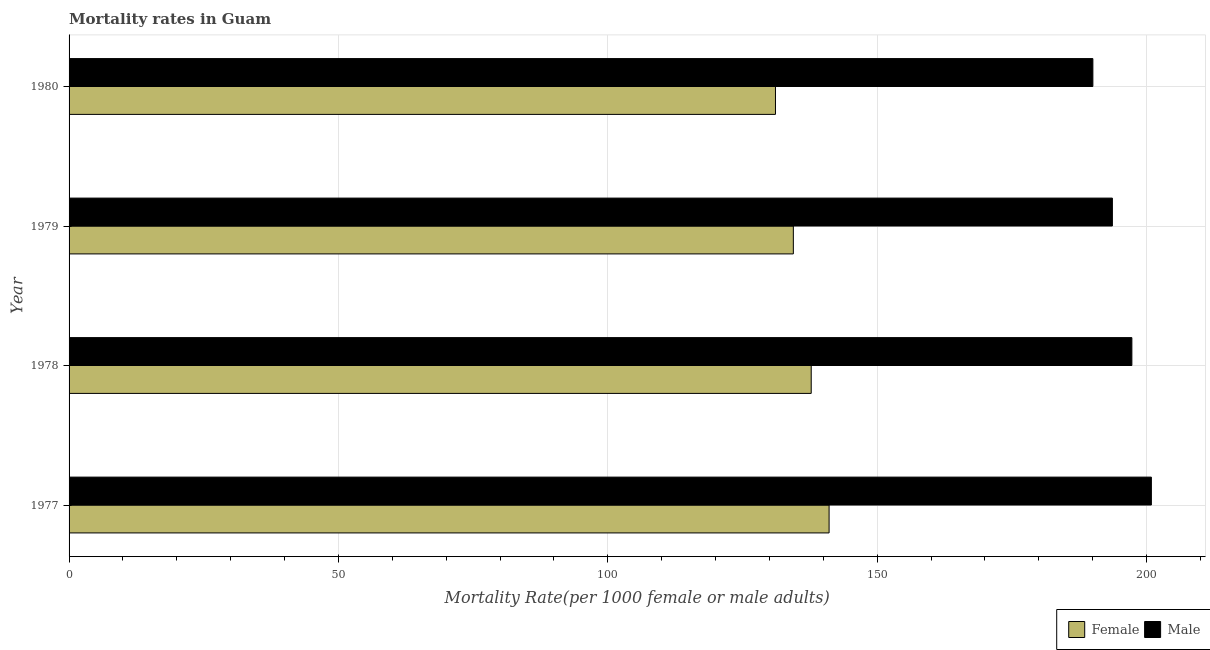How many groups of bars are there?
Provide a succinct answer. 4. Are the number of bars per tick equal to the number of legend labels?
Your answer should be compact. Yes. Are the number of bars on each tick of the Y-axis equal?
Provide a short and direct response. Yes. What is the male mortality rate in 1977?
Provide a short and direct response. 200.9. Across all years, what is the maximum male mortality rate?
Provide a succinct answer. 200.9. Across all years, what is the minimum male mortality rate?
Give a very brief answer. 190.04. What is the total male mortality rate in the graph?
Provide a short and direct response. 781.87. What is the difference between the female mortality rate in 1979 and that in 1980?
Your response must be concise. 3.32. What is the difference between the male mortality rate in 1977 and the female mortality rate in 1980?
Your answer should be compact. 69.78. What is the average female mortality rate per year?
Provide a short and direct response. 136.1. In the year 1979, what is the difference between the female mortality rate and male mortality rate?
Make the answer very short. -59.22. In how many years, is the female mortality rate greater than 10 ?
Provide a succinct answer. 4. What is the ratio of the female mortality rate in 1978 to that in 1980?
Your answer should be very brief. 1.05. Is the difference between the female mortality rate in 1977 and 1979 greater than the difference between the male mortality rate in 1977 and 1979?
Your answer should be very brief. No. What is the difference between the highest and the second highest female mortality rate?
Offer a very short reply. 3.32. What is the difference between the highest and the lowest female mortality rate?
Offer a very short reply. 9.95. Is the sum of the male mortality rate in 1979 and 1980 greater than the maximum female mortality rate across all years?
Offer a very short reply. Yes. What does the 1st bar from the top in 1978 represents?
Keep it short and to the point. Male. How many bars are there?
Provide a short and direct response. 8. Are all the bars in the graph horizontal?
Offer a terse response. Yes. How many years are there in the graph?
Your answer should be very brief. 4. Are the values on the major ticks of X-axis written in scientific E-notation?
Offer a very short reply. No. Does the graph contain grids?
Ensure brevity in your answer.  Yes. How many legend labels are there?
Your answer should be very brief. 2. What is the title of the graph?
Provide a succinct answer. Mortality rates in Guam. What is the label or title of the X-axis?
Give a very brief answer. Mortality Rate(per 1000 female or male adults). What is the Mortality Rate(per 1000 female or male adults) in Female in 1977?
Your answer should be very brief. 141.07. What is the Mortality Rate(per 1000 female or male adults) in Male in 1977?
Provide a short and direct response. 200.9. What is the Mortality Rate(per 1000 female or male adults) in Female in 1978?
Offer a terse response. 137.76. What is the Mortality Rate(per 1000 female or male adults) of Male in 1978?
Provide a succinct answer. 197.28. What is the Mortality Rate(per 1000 female or male adults) in Female in 1979?
Your response must be concise. 134.44. What is the Mortality Rate(per 1000 female or male adults) in Male in 1979?
Offer a terse response. 193.66. What is the Mortality Rate(per 1000 female or male adults) in Female in 1980?
Offer a very short reply. 131.12. What is the Mortality Rate(per 1000 female or male adults) of Male in 1980?
Your answer should be compact. 190.04. Across all years, what is the maximum Mortality Rate(per 1000 female or male adults) in Female?
Provide a succinct answer. 141.07. Across all years, what is the maximum Mortality Rate(per 1000 female or male adults) of Male?
Provide a succinct answer. 200.9. Across all years, what is the minimum Mortality Rate(per 1000 female or male adults) of Female?
Your response must be concise. 131.12. Across all years, what is the minimum Mortality Rate(per 1000 female or male adults) in Male?
Ensure brevity in your answer.  190.04. What is the total Mortality Rate(per 1000 female or male adults) in Female in the graph?
Provide a short and direct response. 544.39. What is the total Mortality Rate(per 1000 female or male adults) of Male in the graph?
Your response must be concise. 781.87. What is the difference between the Mortality Rate(per 1000 female or male adults) of Female in 1977 and that in 1978?
Your answer should be compact. 3.32. What is the difference between the Mortality Rate(per 1000 female or male adults) of Male in 1977 and that in 1978?
Give a very brief answer. 3.62. What is the difference between the Mortality Rate(per 1000 female or male adults) in Female in 1977 and that in 1979?
Your answer should be very brief. 6.64. What is the difference between the Mortality Rate(per 1000 female or male adults) of Male in 1977 and that in 1979?
Your answer should be very brief. 7.24. What is the difference between the Mortality Rate(per 1000 female or male adults) in Female in 1977 and that in 1980?
Give a very brief answer. 9.95. What is the difference between the Mortality Rate(per 1000 female or male adults) of Male in 1977 and that in 1980?
Keep it short and to the point. 10.86. What is the difference between the Mortality Rate(per 1000 female or male adults) in Female in 1978 and that in 1979?
Your response must be concise. 3.32. What is the difference between the Mortality Rate(per 1000 female or male adults) in Male in 1978 and that in 1979?
Provide a succinct answer. 3.62. What is the difference between the Mortality Rate(per 1000 female or male adults) of Female in 1978 and that in 1980?
Provide a short and direct response. 6.63. What is the difference between the Mortality Rate(per 1000 female or male adults) of Male in 1978 and that in 1980?
Your answer should be compact. 7.24. What is the difference between the Mortality Rate(per 1000 female or male adults) of Female in 1979 and that in 1980?
Give a very brief answer. 3.32. What is the difference between the Mortality Rate(per 1000 female or male adults) in Male in 1979 and that in 1980?
Provide a short and direct response. 3.62. What is the difference between the Mortality Rate(per 1000 female or male adults) in Female in 1977 and the Mortality Rate(per 1000 female or male adults) in Male in 1978?
Your answer should be very brief. -56.2. What is the difference between the Mortality Rate(per 1000 female or male adults) of Female in 1977 and the Mortality Rate(per 1000 female or male adults) of Male in 1979?
Give a very brief answer. -52.59. What is the difference between the Mortality Rate(per 1000 female or male adults) in Female in 1977 and the Mortality Rate(per 1000 female or male adults) in Male in 1980?
Your answer should be very brief. -48.97. What is the difference between the Mortality Rate(per 1000 female or male adults) of Female in 1978 and the Mortality Rate(per 1000 female or male adults) of Male in 1979?
Keep it short and to the point. -55.9. What is the difference between the Mortality Rate(per 1000 female or male adults) of Female in 1978 and the Mortality Rate(per 1000 female or male adults) of Male in 1980?
Keep it short and to the point. -52.28. What is the difference between the Mortality Rate(per 1000 female or male adults) of Female in 1979 and the Mortality Rate(per 1000 female or male adults) of Male in 1980?
Provide a succinct answer. -55.6. What is the average Mortality Rate(per 1000 female or male adults) of Female per year?
Make the answer very short. 136.1. What is the average Mortality Rate(per 1000 female or male adults) of Male per year?
Offer a very short reply. 195.47. In the year 1977, what is the difference between the Mortality Rate(per 1000 female or male adults) of Female and Mortality Rate(per 1000 female or male adults) of Male?
Provide a short and direct response. -59.82. In the year 1978, what is the difference between the Mortality Rate(per 1000 female or male adults) in Female and Mortality Rate(per 1000 female or male adults) in Male?
Your answer should be very brief. -59.52. In the year 1979, what is the difference between the Mortality Rate(per 1000 female or male adults) of Female and Mortality Rate(per 1000 female or male adults) of Male?
Give a very brief answer. -59.22. In the year 1980, what is the difference between the Mortality Rate(per 1000 female or male adults) in Female and Mortality Rate(per 1000 female or male adults) in Male?
Ensure brevity in your answer.  -58.92. What is the ratio of the Mortality Rate(per 1000 female or male adults) of Female in 1977 to that in 1978?
Your answer should be compact. 1.02. What is the ratio of the Mortality Rate(per 1000 female or male adults) in Male in 1977 to that in 1978?
Ensure brevity in your answer.  1.02. What is the ratio of the Mortality Rate(per 1000 female or male adults) of Female in 1977 to that in 1979?
Your answer should be compact. 1.05. What is the ratio of the Mortality Rate(per 1000 female or male adults) in Male in 1977 to that in 1979?
Provide a succinct answer. 1.04. What is the ratio of the Mortality Rate(per 1000 female or male adults) of Female in 1977 to that in 1980?
Your answer should be very brief. 1.08. What is the ratio of the Mortality Rate(per 1000 female or male adults) of Male in 1977 to that in 1980?
Make the answer very short. 1.06. What is the ratio of the Mortality Rate(per 1000 female or male adults) in Female in 1978 to that in 1979?
Offer a very short reply. 1.02. What is the ratio of the Mortality Rate(per 1000 female or male adults) of Male in 1978 to that in 1979?
Provide a short and direct response. 1.02. What is the ratio of the Mortality Rate(per 1000 female or male adults) of Female in 1978 to that in 1980?
Keep it short and to the point. 1.05. What is the ratio of the Mortality Rate(per 1000 female or male adults) of Male in 1978 to that in 1980?
Keep it short and to the point. 1.04. What is the ratio of the Mortality Rate(per 1000 female or male adults) of Female in 1979 to that in 1980?
Offer a terse response. 1.03. What is the difference between the highest and the second highest Mortality Rate(per 1000 female or male adults) in Female?
Provide a succinct answer. 3.32. What is the difference between the highest and the second highest Mortality Rate(per 1000 female or male adults) of Male?
Offer a very short reply. 3.62. What is the difference between the highest and the lowest Mortality Rate(per 1000 female or male adults) in Female?
Keep it short and to the point. 9.95. What is the difference between the highest and the lowest Mortality Rate(per 1000 female or male adults) in Male?
Your answer should be compact. 10.86. 